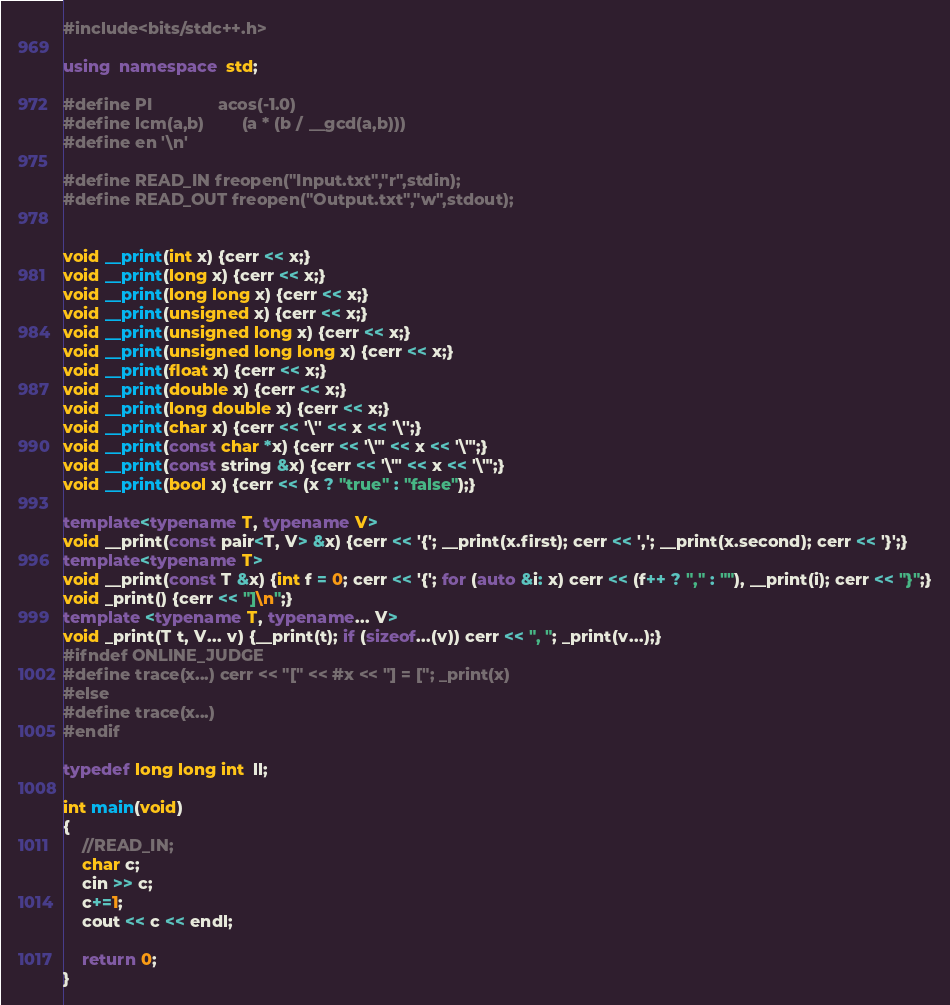Convert code to text. <code><loc_0><loc_0><loc_500><loc_500><_C++_>#include<bits/stdc++.h>

using  namespace  std;

#define PI              acos(-1.0)
#define lcm(a,b)        (a * (b / __gcd(a,b)))
#define en '\n'

#define READ_IN freopen("Input.txt","r",stdin);
#define READ_OUT freopen("Output.txt","w",stdout);


void __print(int x) {cerr << x;}
void __print(long x) {cerr << x;}
void __print(long long x) {cerr << x;}
void __print(unsigned x) {cerr << x;}
void __print(unsigned long x) {cerr << x;}
void __print(unsigned long long x) {cerr << x;}
void __print(float x) {cerr << x;}
void __print(double x) {cerr << x;}
void __print(long double x) {cerr << x;}
void __print(char x) {cerr << '\'' << x << '\'';}
void __print(const char *x) {cerr << '\"' << x << '\"';}
void __print(const string &x) {cerr << '\"' << x << '\"';}
void __print(bool x) {cerr << (x ? "true" : "false");}

template<typename T, typename V>
void __print(const pair<T, V> &x) {cerr << '{'; __print(x.first); cerr << ','; __print(x.second); cerr << '}';}
template<typename T>
void __print(const T &x) {int f = 0; cerr << '{'; for (auto &i: x) cerr << (f++ ? "," : ""), __print(i); cerr << "}";}
void _print() {cerr << "]\n";}
template <typename T, typename... V>
void _print(T t, V... v) {__print(t); if (sizeof...(v)) cerr << ", "; _print(v...);}
#ifndef ONLINE_JUDGE
#define trace(x...) cerr << "[" << #x << "] = ["; _print(x)
#else
#define trace(x...)
#endif

typedef long long int  ll;

int main(void)
{
    //READ_IN;
    char c;
    cin >> c;
    c+=1;
    cout << c << endl;

    return 0;
}
</code> 